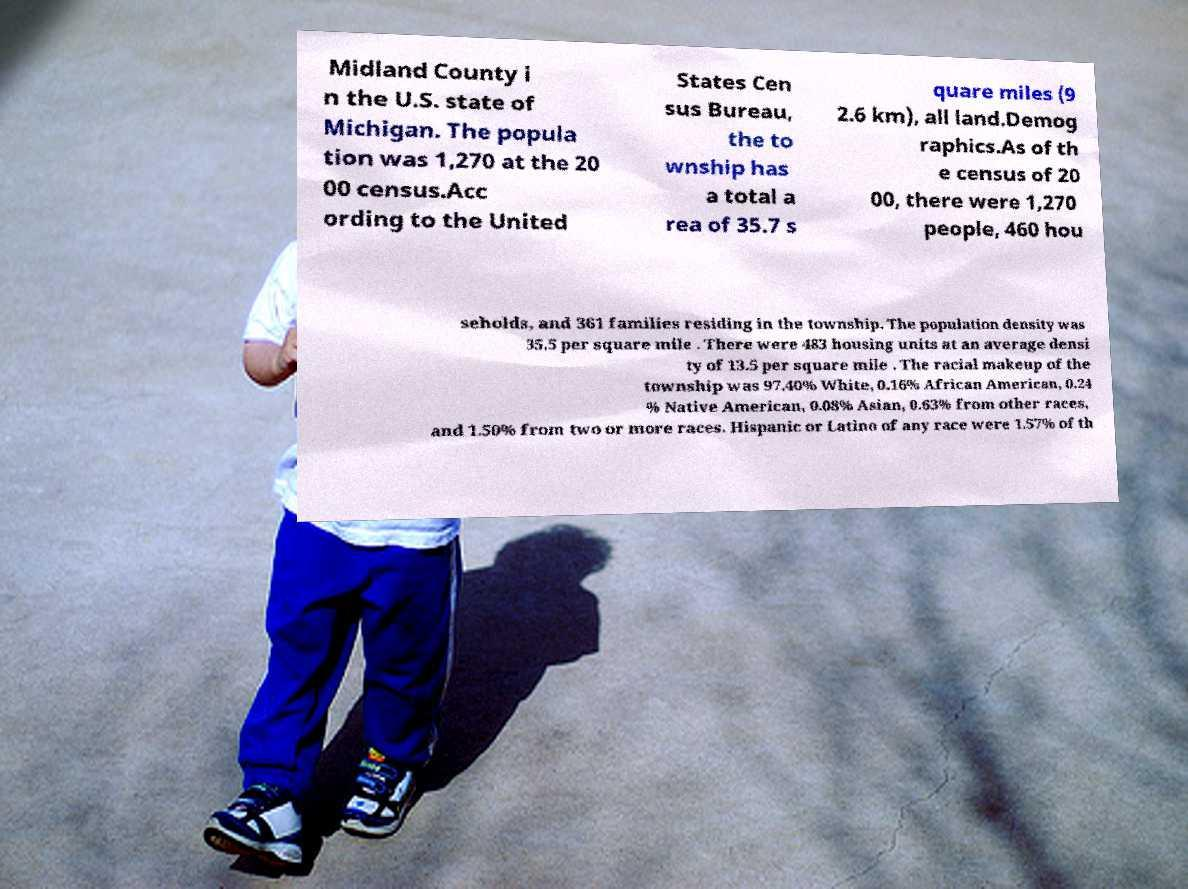Can you accurately transcribe the text from the provided image for me? Midland County i n the U.S. state of Michigan. The popula tion was 1,270 at the 20 00 census.Acc ording to the United States Cen sus Bureau, the to wnship has a total a rea of 35.7 s quare miles (9 2.6 km), all land.Demog raphics.As of th e census of 20 00, there were 1,270 people, 460 hou seholds, and 361 families residing in the township. The population density was 35.5 per square mile . There were 483 housing units at an average densi ty of 13.5 per square mile . The racial makeup of the township was 97.40% White, 0.16% African American, 0.24 % Native American, 0.08% Asian, 0.63% from other races, and 1.50% from two or more races. Hispanic or Latino of any race were 1.57% of th 